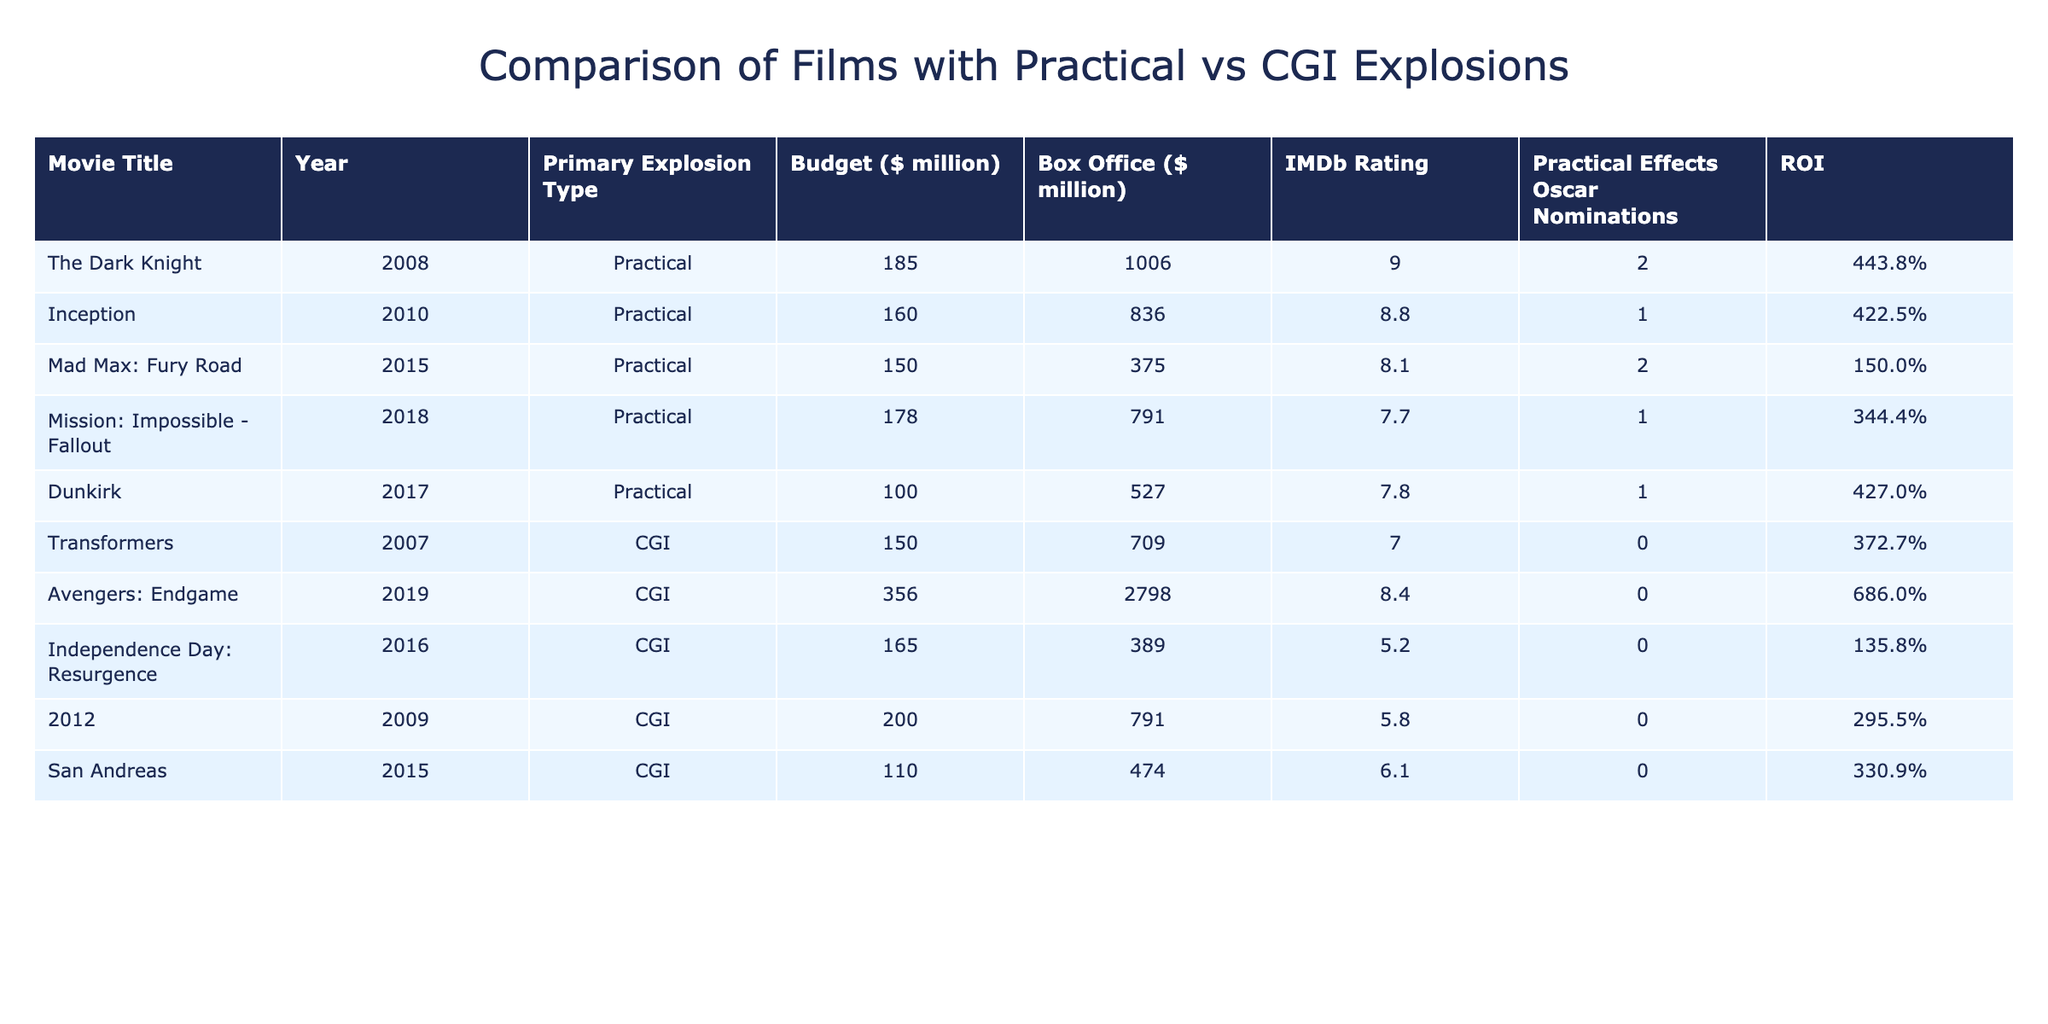What is the box office earnings of "The Dark Knight"? The box office earnings of "The Dark Knight" is listed directly in the table under the Box Office column, which shows 1006 million dollars.
Answer: 1006 million dollars Which movie had the highest budget among the films with practical explosions? The "Budget ($ million)" column allows us to identify the budgets for films with practical explosions. "Mission: Impossible - Fallout" has a budget of 178 million dollars, which is higher than other entries in the same column.
Answer: 178 million dollars How many films featuring CGI explosions had a box office greater than 700 million dollars? By reviewing the "Box Office ($ million)" column for CGI films, only "Transformers" (709 million) and "Avengers: Endgame" (2798 million) exceed 700 million. Therefore, there are two films that meet this criterion.
Answer: 2 What is the average IMDb rating of the films that used practical effects? The IMDb ratings for practical films are 9.0 for "The Dark Knight," 8.8 for "Inception," 8.1 for "Mad Max: Fury Road," 7.7 for "Mission: Impossible - Fallout," and 7.8 for "Dunkirk." Adding these gives 9.0 + 8.8 + 8.1 + 7.7 + 7.8 = 42.4. Dividing by 5 (the number of films) gives an average rating of 8.48.
Answer: 8.48 Is it true that "Independence Day: Resurgence" received an Oscar nomination for practical effects? The "Practical Effects Oscar Nominations" column shows that "Independence Day: Resurgence" has 0 nominations, indicating that it did not receive any. Thus, the statement is false.
Answer: No 